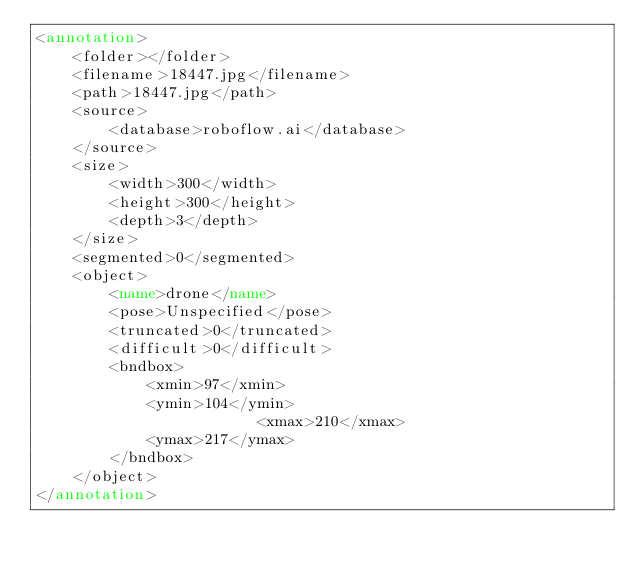Convert code to text. <code><loc_0><loc_0><loc_500><loc_500><_XML_><annotation>
	<folder></folder>
	<filename>18447.jpg</filename>
	<path>18447.jpg</path>
	<source>
		<database>roboflow.ai</database>
	</source>
	<size>
		<width>300</width>
		<height>300</height>
		<depth>3</depth>
	</size>
	<segmented>0</segmented>
	<object>
		<name>drone</name>
		<pose>Unspecified</pose>
		<truncated>0</truncated>
		<difficult>0</difficult>
		<bndbox>
			<xmin>97</xmin>
			<ymin>104</ymin>
                        <xmax>210</xmax>
			<ymax>217</ymax>
		</bndbox>
	</object>
</annotation>
</code> 